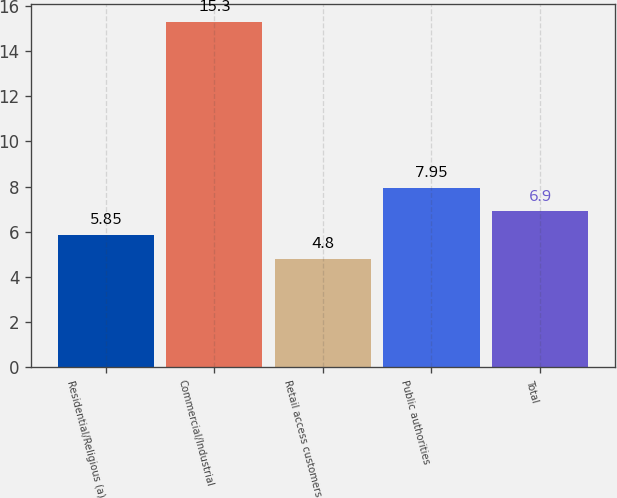Convert chart to OTSL. <chart><loc_0><loc_0><loc_500><loc_500><bar_chart><fcel>Residential/Religious (a)<fcel>Commercial/Industrial<fcel>Retail access customers<fcel>Public authorities<fcel>Total<nl><fcel>5.85<fcel>15.3<fcel>4.8<fcel>7.95<fcel>6.9<nl></chart> 